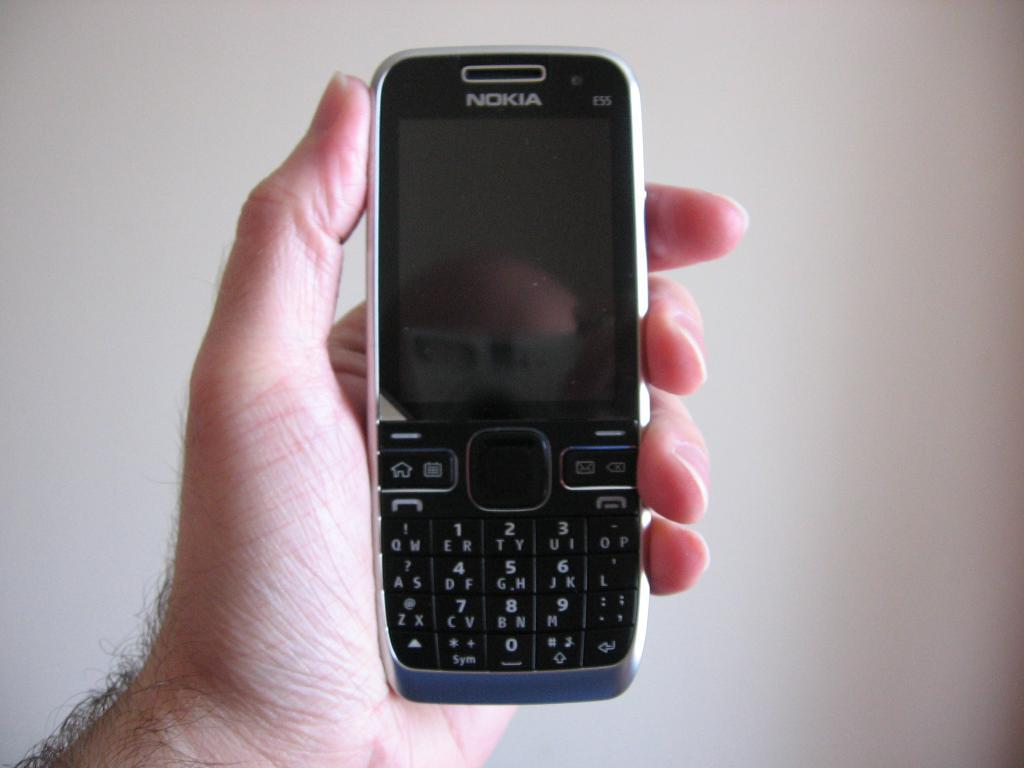Provide a one-sentence caption for the provided image. Nokia phone is being held in somebody hand. 